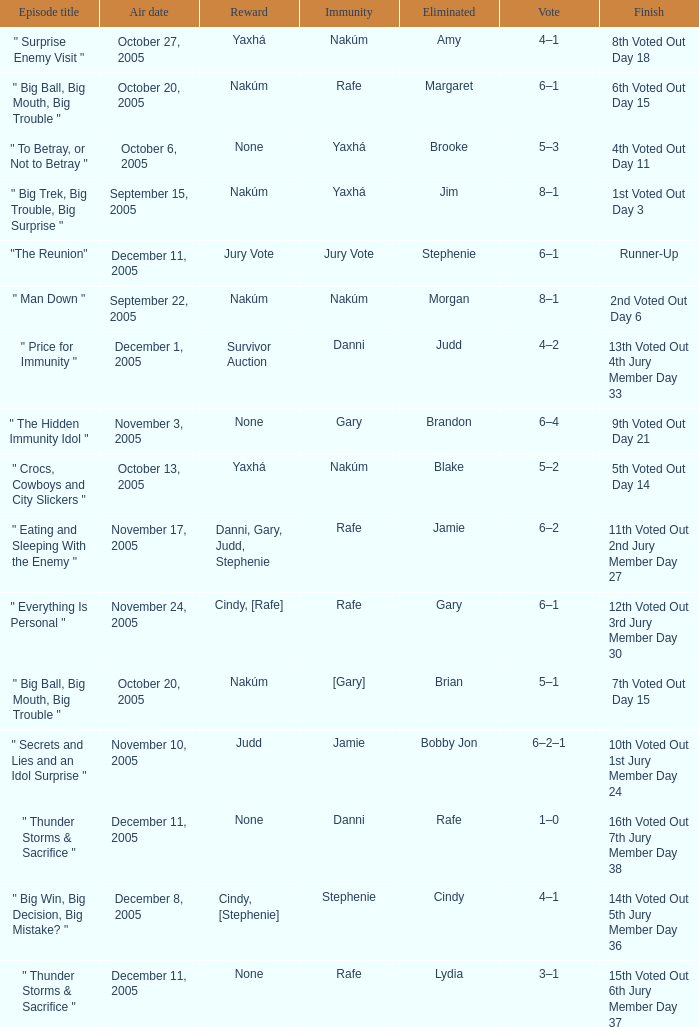How many air dates were there when Morgan was eliminated? 1.0. 